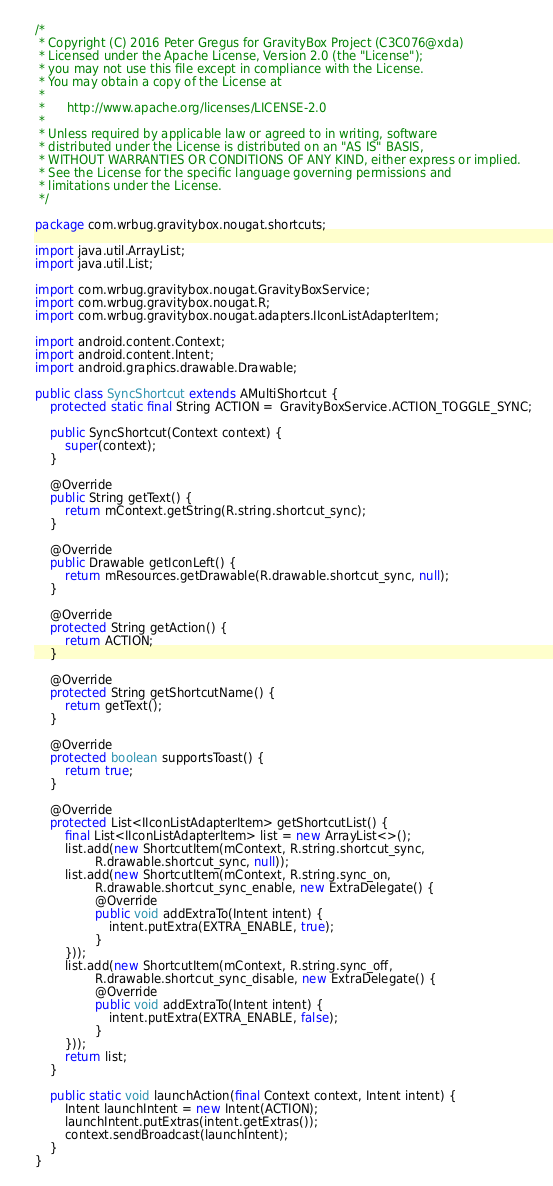<code> <loc_0><loc_0><loc_500><loc_500><_Java_>/*
 * Copyright (C) 2016 Peter Gregus for GravityBox Project (C3C076@xda)
 * Licensed under the Apache License, Version 2.0 (the "License");
 * you may not use this file except in compliance with the License.
 * You may obtain a copy of the License at
 *
 *      http://www.apache.org/licenses/LICENSE-2.0
 *
 * Unless required by applicable law or agreed to in writing, software
 * distributed under the License is distributed on an "AS IS" BASIS,
 * WITHOUT WARRANTIES OR CONDITIONS OF ANY KIND, either express or implied.
 * See the License for the specific language governing permissions and
 * limitations under the License.
 */

package com.wrbug.gravitybox.nougat.shortcuts;

import java.util.ArrayList;
import java.util.List;

import com.wrbug.gravitybox.nougat.GravityBoxService;
import com.wrbug.gravitybox.nougat.R;
import com.wrbug.gravitybox.nougat.adapters.IIconListAdapterItem;

import android.content.Context;
import android.content.Intent;
import android.graphics.drawable.Drawable;

public class SyncShortcut extends AMultiShortcut {
    protected static final String ACTION =  GravityBoxService.ACTION_TOGGLE_SYNC;

    public SyncShortcut(Context context) {
        super(context);
    }

    @Override
    public String getText() {
        return mContext.getString(R.string.shortcut_sync);
    }

    @Override
    public Drawable getIconLeft() {
        return mResources.getDrawable(R.drawable.shortcut_sync, null);
    }

    @Override
    protected String getAction() {
        return ACTION;
    }

    @Override
    protected String getShortcutName() {
        return getText();
    }

    @Override
    protected boolean supportsToast() {
        return true;
    }

    @Override
    protected List<IIconListAdapterItem> getShortcutList() {
        final List<IIconListAdapterItem> list = new ArrayList<>();
        list.add(new ShortcutItem(mContext, R.string.shortcut_sync,
                R.drawable.shortcut_sync, null));
        list.add(new ShortcutItem(mContext, R.string.sync_on,
                R.drawable.shortcut_sync_enable, new ExtraDelegate() {
                @Override
                public void addExtraTo(Intent intent) {
                    intent.putExtra(EXTRA_ENABLE, true);
                }
        }));
        list.add(new ShortcutItem(mContext, R.string.sync_off,
                R.drawable.shortcut_sync_disable, new ExtraDelegate() {
                @Override
                public void addExtraTo(Intent intent) {
                    intent.putExtra(EXTRA_ENABLE, false);
                }
        }));
        return list;
    }

    public static void launchAction(final Context context, Intent intent) {
        Intent launchIntent = new Intent(ACTION);
        launchIntent.putExtras(intent.getExtras());
        context.sendBroadcast(launchIntent);
    }
}
</code> 